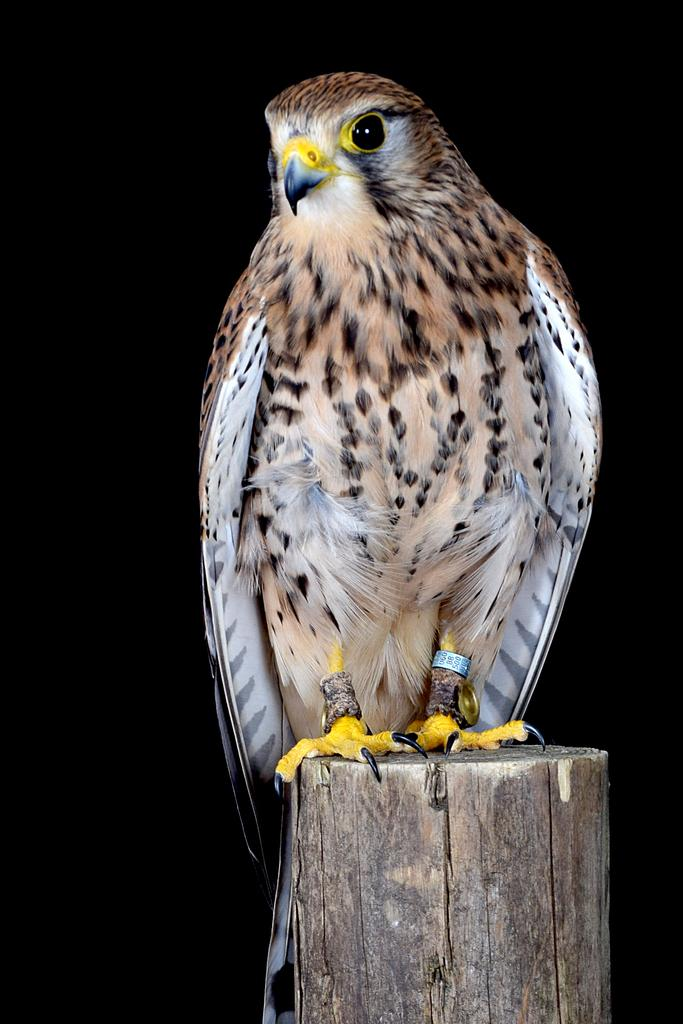What animal is present in the image? There is an owl in the image. What is the owl sitting on? The owl is on a wooden log. What colors can be seen on the owl? The owl has brown, black, and white colors. What is the color of the background in the image? The background of the image is black. What type of news can be heard in the background of the image? There is no sound or news present in the image; it is a still image of an owl on a wooden log. 